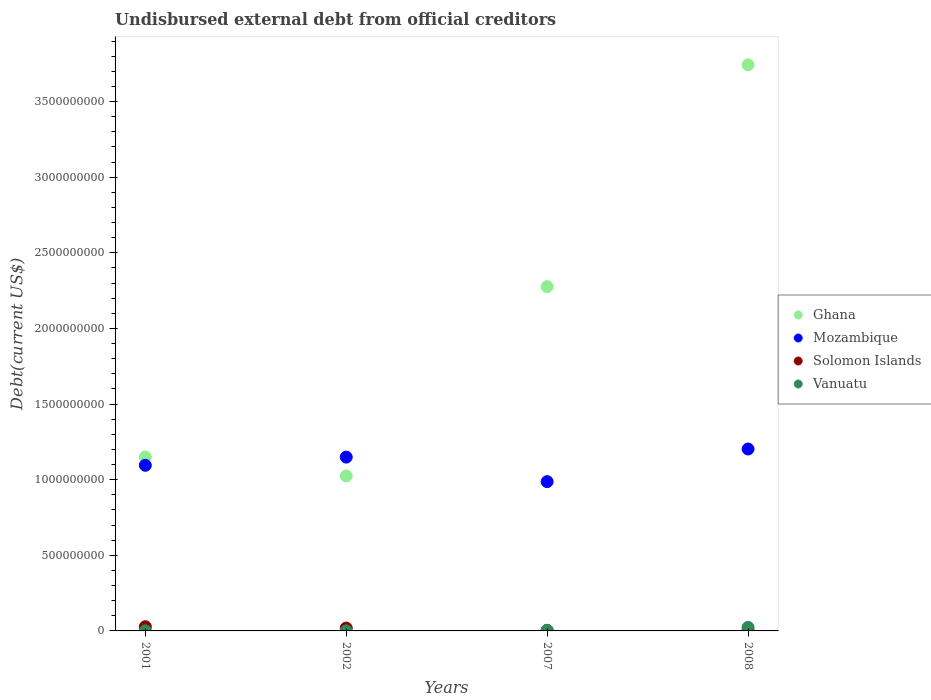How many different coloured dotlines are there?
Provide a short and direct response. 4. Is the number of dotlines equal to the number of legend labels?
Your answer should be very brief. Yes. What is the total debt in Solomon Islands in 2001?
Your response must be concise. 2.78e+07. Across all years, what is the maximum total debt in Mozambique?
Keep it short and to the point. 1.20e+09. Across all years, what is the minimum total debt in Mozambique?
Your response must be concise. 9.87e+08. What is the total total debt in Solomon Islands in the graph?
Offer a terse response. 5.38e+07. What is the difference between the total debt in Mozambique in 2001 and that in 2008?
Offer a very short reply. -1.08e+08. What is the difference between the total debt in Ghana in 2001 and the total debt in Vanuatu in 2007?
Offer a terse response. 1.15e+09. What is the average total debt in Mozambique per year?
Offer a terse response. 1.11e+09. In the year 2001, what is the difference between the total debt in Solomon Islands and total debt in Ghana?
Provide a short and direct response. -1.12e+09. In how many years, is the total debt in Mozambique greater than 3400000000 US$?
Your answer should be compact. 0. What is the ratio of the total debt in Ghana in 2007 to that in 2008?
Your answer should be very brief. 0.61. Is the total debt in Solomon Islands in 2001 less than that in 2002?
Your answer should be compact. No. What is the difference between the highest and the second highest total debt in Vanuatu?
Provide a short and direct response. 1.92e+07. What is the difference between the highest and the lowest total debt in Solomon Islands?
Offer a terse response. 2.43e+07. Is the sum of the total debt in Mozambique in 2002 and 2007 greater than the maximum total debt in Ghana across all years?
Make the answer very short. No. Is it the case that in every year, the sum of the total debt in Mozambique and total debt in Solomon Islands  is greater than the total debt in Vanuatu?
Offer a very short reply. Yes. Does the total debt in Solomon Islands monotonically increase over the years?
Offer a very short reply. No. Is the total debt in Mozambique strictly greater than the total debt in Vanuatu over the years?
Your answer should be compact. Yes. Is the total debt in Mozambique strictly less than the total debt in Solomon Islands over the years?
Ensure brevity in your answer.  No. Are the values on the major ticks of Y-axis written in scientific E-notation?
Offer a terse response. No. Does the graph contain grids?
Make the answer very short. No. How are the legend labels stacked?
Your answer should be very brief. Vertical. What is the title of the graph?
Your answer should be very brief. Undisbursed external debt from official creditors. What is the label or title of the X-axis?
Ensure brevity in your answer.  Years. What is the label or title of the Y-axis?
Ensure brevity in your answer.  Debt(current US$). What is the Debt(current US$) in Ghana in 2001?
Provide a short and direct response. 1.15e+09. What is the Debt(current US$) of Mozambique in 2001?
Make the answer very short. 1.09e+09. What is the Debt(current US$) of Solomon Islands in 2001?
Make the answer very short. 2.78e+07. What is the Debt(current US$) in Vanuatu in 2001?
Provide a short and direct response. 5.09e+05. What is the Debt(current US$) in Ghana in 2002?
Your answer should be very brief. 1.02e+09. What is the Debt(current US$) in Mozambique in 2002?
Ensure brevity in your answer.  1.15e+09. What is the Debt(current US$) in Solomon Islands in 2002?
Offer a very short reply. 1.89e+07. What is the Debt(current US$) of Vanuatu in 2002?
Make the answer very short. 1.20e+04. What is the Debt(current US$) of Ghana in 2007?
Your answer should be compact. 2.28e+09. What is the Debt(current US$) of Mozambique in 2007?
Make the answer very short. 9.87e+08. What is the Debt(current US$) in Solomon Islands in 2007?
Keep it short and to the point. 3.60e+06. What is the Debt(current US$) of Vanuatu in 2007?
Make the answer very short. 4.20e+06. What is the Debt(current US$) of Ghana in 2008?
Keep it short and to the point. 3.74e+09. What is the Debt(current US$) of Mozambique in 2008?
Your response must be concise. 1.20e+09. What is the Debt(current US$) in Solomon Islands in 2008?
Provide a short and direct response. 3.46e+06. What is the Debt(current US$) of Vanuatu in 2008?
Offer a terse response. 2.34e+07. Across all years, what is the maximum Debt(current US$) in Ghana?
Make the answer very short. 3.74e+09. Across all years, what is the maximum Debt(current US$) in Mozambique?
Your answer should be very brief. 1.20e+09. Across all years, what is the maximum Debt(current US$) of Solomon Islands?
Your response must be concise. 2.78e+07. Across all years, what is the maximum Debt(current US$) in Vanuatu?
Your answer should be very brief. 2.34e+07. Across all years, what is the minimum Debt(current US$) of Ghana?
Provide a short and direct response. 1.02e+09. Across all years, what is the minimum Debt(current US$) in Mozambique?
Your answer should be compact. 9.87e+08. Across all years, what is the minimum Debt(current US$) in Solomon Islands?
Give a very brief answer. 3.46e+06. Across all years, what is the minimum Debt(current US$) of Vanuatu?
Make the answer very short. 1.20e+04. What is the total Debt(current US$) of Ghana in the graph?
Your answer should be very brief. 8.19e+09. What is the total Debt(current US$) in Mozambique in the graph?
Keep it short and to the point. 4.43e+09. What is the total Debt(current US$) in Solomon Islands in the graph?
Provide a succinct answer. 5.38e+07. What is the total Debt(current US$) of Vanuatu in the graph?
Provide a succinct answer. 2.82e+07. What is the difference between the Debt(current US$) of Ghana in 2001 and that in 2002?
Ensure brevity in your answer.  1.25e+08. What is the difference between the Debt(current US$) of Mozambique in 2001 and that in 2002?
Provide a succinct answer. -5.41e+07. What is the difference between the Debt(current US$) in Solomon Islands in 2001 and that in 2002?
Your answer should be very brief. 8.89e+06. What is the difference between the Debt(current US$) in Vanuatu in 2001 and that in 2002?
Make the answer very short. 4.97e+05. What is the difference between the Debt(current US$) in Ghana in 2001 and that in 2007?
Your answer should be compact. -1.13e+09. What is the difference between the Debt(current US$) of Mozambique in 2001 and that in 2007?
Your response must be concise. 1.08e+08. What is the difference between the Debt(current US$) of Solomon Islands in 2001 and that in 2007?
Your answer should be very brief. 2.42e+07. What is the difference between the Debt(current US$) in Vanuatu in 2001 and that in 2007?
Keep it short and to the point. -3.69e+06. What is the difference between the Debt(current US$) in Ghana in 2001 and that in 2008?
Provide a succinct answer. -2.59e+09. What is the difference between the Debt(current US$) of Mozambique in 2001 and that in 2008?
Your answer should be compact. -1.08e+08. What is the difference between the Debt(current US$) in Solomon Islands in 2001 and that in 2008?
Make the answer very short. 2.43e+07. What is the difference between the Debt(current US$) in Vanuatu in 2001 and that in 2008?
Ensure brevity in your answer.  -2.29e+07. What is the difference between the Debt(current US$) in Ghana in 2002 and that in 2007?
Offer a very short reply. -1.25e+09. What is the difference between the Debt(current US$) in Mozambique in 2002 and that in 2007?
Offer a terse response. 1.62e+08. What is the difference between the Debt(current US$) in Solomon Islands in 2002 and that in 2007?
Offer a terse response. 1.53e+07. What is the difference between the Debt(current US$) in Vanuatu in 2002 and that in 2007?
Offer a very short reply. -4.19e+06. What is the difference between the Debt(current US$) in Ghana in 2002 and that in 2008?
Your answer should be very brief. -2.72e+09. What is the difference between the Debt(current US$) in Mozambique in 2002 and that in 2008?
Your answer should be very brief. -5.36e+07. What is the difference between the Debt(current US$) of Solomon Islands in 2002 and that in 2008?
Your answer should be very brief. 1.54e+07. What is the difference between the Debt(current US$) of Vanuatu in 2002 and that in 2008?
Provide a short and direct response. -2.34e+07. What is the difference between the Debt(current US$) of Ghana in 2007 and that in 2008?
Provide a succinct answer. -1.47e+09. What is the difference between the Debt(current US$) of Mozambique in 2007 and that in 2008?
Offer a very short reply. -2.16e+08. What is the difference between the Debt(current US$) in Solomon Islands in 2007 and that in 2008?
Make the answer very short. 1.39e+05. What is the difference between the Debt(current US$) of Vanuatu in 2007 and that in 2008?
Make the answer very short. -1.92e+07. What is the difference between the Debt(current US$) of Ghana in 2001 and the Debt(current US$) of Mozambique in 2002?
Provide a succinct answer. 6.77e+05. What is the difference between the Debt(current US$) in Ghana in 2001 and the Debt(current US$) in Solomon Islands in 2002?
Offer a terse response. 1.13e+09. What is the difference between the Debt(current US$) of Ghana in 2001 and the Debt(current US$) of Vanuatu in 2002?
Your answer should be compact. 1.15e+09. What is the difference between the Debt(current US$) in Mozambique in 2001 and the Debt(current US$) in Solomon Islands in 2002?
Keep it short and to the point. 1.08e+09. What is the difference between the Debt(current US$) of Mozambique in 2001 and the Debt(current US$) of Vanuatu in 2002?
Your answer should be very brief. 1.09e+09. What is the difference between the Debt(current US$) of Solomon Islands in 2001 and the Debt(current US$) of Vanuatu in 2002?
Your response must be concise. 2.78e+07. What is the difference between the Debt(current US$) in Ghana in 2001 and the Debt(current US$) in Mozambique in 2007?
Provide a succinct answer. 1.63e+08. What is the difference between the Debt(current US$) of Ghana in 2001 and the Debt(current US$) of Solomon Islands in 2007?
Ensure brevity in your answer.  1.15e+09. What is the difference between the Debt(current US$) in Ghana in 2001 and the Debt(current US$) in Vanuatu in 2007?
Your answer should be very brief. 1.15e+09. What is the difference between the Debt(current US$) in Mozambique in 2001 and the Debt(current US$) in Solomon Islands in 2007?
Ensure brevity in your answer.  1.09e+09. What is the difference between the Debt(current US$) in Mozambique in 2001 and the Debt(current US$) in Vanuatu in 2007?
Give a very brief answer. 1.09e+09. What is the difference between the Debt(current US$) of Solomon Islands in 2001 and the Debt(current US$) of Vanuatu in 2007?
Offer a very short reply. 2.36e+07. What is the difference between the Debt(current US$) in Ghana in 2001 and the Debt(current US$) in Mozambique in 2008?
Provide a short and direct response. -5.29e+07. What is the difference between the Debt(current US$) in Ghana in 2001 and the Debt(current US$) in Solomon Islands in 2008?
Provide a succinct answer. 1.15e+09. What is the difference between the Debt(current US$) in Ghana in 2001 and the Debt(current US$) in Vanuatu in 2008?
Your answer should be very brief. 1.13e+09. What is the difference between the Debt(current US$) in Mozambique in 2001 and the Debt(current US$) in Solomon Islands in 2008?
Provide a short and direct response. 1.09e+09. What is the difference between the Debt(current US$) of Mozambique in 2001 and the Debt(current US$) of Vanuatu in 2008?
Offer a very short reply. 1.07e+09. What is the difference between the Debt(current US$) in Solomon Islands in 2001 and the Debt(current US$) in Vanuatu in 2008?
Offer a very short reply. 4.36e+06. What is the difference between the Debt(current US$) in Ghana in 2002 and the Debt(current US$) in Mozambique in 2007?
Ensure brevity in your answer.  3.77e+07. What is the difference between the Debt(current US$) of Ghana in 2002 and the Debt(current US$) of Solomon Islands in 2007?
Your response must be concise. 1.02e+09. What is the difference between the Debt(current US$) of Ghana in 2002 and the Debt(current US$) of Vanuatu in 2007?
Your answer should be very brief. 1.02e+09. What is the difference between the Debt(current US$) of Mozambique in 2002 and the Debt(current US$) of Solomon Islands in 2007?
Provide a short and direct response. 1.15e+09. What is the difference between the Debt(current US$) of Mozambique in 2002 and the Debt(current US$) of Vanuatu in 2007?
Provide a succinct answer. 1.14e+09. What is the difference between the Debt(current US$) in Solomon Islands in 2002 and the Debt(current US$) in Vanuatu in 2007?
Give a very brief answer. 1.47e+07. What is the difference between the Debt(current US$) in Ghana in 2002 and the Debt(current US$) in Mozambique in 2008?
Your response must be concise. -1.78e+08. What is the difference between the Debt(current US$) in Ghana in 2002 and the Debt(current US$) in Solomon Islands in 2008?
Offer a very short reply. 1.02e+09. What is the difference between the Debt(current US$) in Ghana in 2002 and the Debt(current US$) in Vanuatu in 2008?
Keep it short and to the point. 1.00e+09. What is the difference between the Debt(current US$) in Mozambique in 2002 and the Debt(current US$) in Solomon Islands in 2008?
Offer a terse response. 1.15e+09. What is the difference between the Debt(current US$) of Mozambique in 2002 and the Debt(current US$) of Vanuatu in 2008?
Provide a succinct answer. 1.13e+09. What is the difference between the Debt(current US$) of Solomon Islands in 2002 and the Debt(current US$) of Vanuatu in 2008?
Keep it short and to the point. -4.53e+06. What is the difference between the Debt(current US$) in Ghana in 2007 and the Debt(current US$) in Mozambique in 2008?
Provide a succinct answer. 1.07e+09. What is the difference between the Debt(current US$) in Ghana in 2007 and the Debt(current US$) in Solomon Islands in 2008?
Your answer should be very brief. 2.27e+09. What is the difference between the Debt(current US$) in Ghana in 2007 and the Debt(current US$) in Vanuatu in 2008?
Ensure brevity in your answer.  2.25e+09. What is the difference between the Debt(current US$) in Mozambique in 2007 and the Debt(current US$) in Solomon Islands in 2008?
Your answer should be compact. 9.83e+08. What is the difference between the Debt(current US$) of Mozambique in 2007 and the Debt(current US$) of Vanuatu in 2008?
Offer a terse response. 9.64e+08. What is the difference between the Debt(current US$) of Solomon Islands in 2007 and the Debt(current US$) of Vanuatu in 2008?
Make the answer very short. -1.98e+07. What is the average Debt(current US$) in Ghana per year?
Give a very brief answer. 2.05e+09. What is the average Debt(current US$) in Mozambique per year?
Provide a short and direct response. 1.11e+09. What is the average Debt(current US$) in Solomon Islands per year?
Provide a short and direct response. 1.34e+07. What is the average Debt(current US$) of Vanuatu per year?
Give a very brief answer. 7.04e+06. In the year 2001, what is the difference between the Debt(current US$) in Ghana and Debt(current US$) in Mozambique?
Your response must be concise. 5.48e+07. In the year 2001, what is the difference between the Debt(current US$) of Ghana and Debt(current US$) of Solomon Islands?
Provide a short and direct response. 1.12e+09. In the year 2001, what is the difference between the Debt(current US$) in Ghana and Debt(current US$) in Vanuatu?
Your response must be concise. 1.15e+09. In the year 2001, what is the difference between the Debt(current US$) in Mozambique and Debt(current US$) in Solomon Islands?
Make the answer very short. 1.07e+09. In the year 2001, what is the difference between the Debt(current US$) of Mozambique and Debt(current US$) of Vanuatu?
Your answer should be compact. 1.09e+09. In the year 2001, what is the difference between the Debt(current US$) of Solomon Islands and Debt(current US$) of Vanuatu?
Your answer should be compact. 2.73e+07. In the year 2002, what is the difference between the Debt(current US$) in Ghana and Debt(current US$) in Mozambique?
Make the answer very short. -1.24e+08. In the year 2002, what is the difference between the Debt(current US$) of Ghana and Debt(current US$) of Solomon Islands?
Provide a succinct answer. 1.01e+09. In the year 2002, what is the difference between the Debt(current US$) in Ghana and Debt(current US$) in Vanuatu?
Ensure brevity in your answer.  1.02e+09. In the year 2002, what is the difference between the Debt(current US$) in Mozambique and Debt(current US$) in Solomon Islands?
Keep it short and to the point. 1.13e+09. In the year 2002, what is the difference between the Debt(current US$) in Mozambique and Debt(current US$) in Vanuatu?
Your answer should be very brief. 1.15e+09. In the year 2002, what is the difference between the Debt(current US$) of Solomon Islands and Debt(current US$) of Vanuatu?
Offer a terse response. 1.89e+07. In the year 2007, what is the difference between the Debt(current US$) in Ghana and Debt(current US$) in Mozambique?
Provide a short and direct response. 1.29e+09. In the year 2007, what is the difference between the Debt(current US$) of Ghana and Debt(current US$) of Solomon Islands?
Provide a short and direct response. 2.27e+09. In the year 2007, what is the difference between the Debt(current US$) in Ghana and Debt(current US$) in Vanuatu?
Provide a succinct answer. 2.27e+09. In the year 2007, what is the difference between the Debt(current US$) in Mozambique and Debt(current US$) in Solomon Islands?
Provide a short and direct response. 9.83e+08. In the year 2007, what is the difference between the Debt(current US$) in Mozambique and Debt(current US$) in Vanuatu?
Your answer should be compact. 9.83e+08. In the year 2007, what is the difference between the Debt(current US$) of Solomon Islands and Debt(current US$) of Vanuatu?
Keep it short and to the point. -5.96e+05. In the year 2008, what is the difference between the Debt(current US$) of Ghana and Debt(current US$) of Mozambique?
Provide a short and direct response. 2.54e+09. In the year 2008, what is the difference between the Debt(current US$) in Ghana and Debt(current US$) in Solomon Islands?
Ensure brevity in your answer.  3.74e+09. In the year 2008, what is the difference between the Debt(current US$) in Ghana and Debt(current US$) in Vanuatu?
Offer a terse response. 3.72e+09. In the year 2008, what is the difference between the Debt(current US$) of Mozambique and Debt(current US$) of Solomon Islands?
Offer a very short reply. 1.20e+09. In the year 2008, what is the difference between the Debt(current US$) in Mozambique and Debt(current US$) in Vanuatu?
Ensure brevity in your answer.  1.18e+09. In the year 2008, what is the difference between the Debt(current US$) of Solomon Islands and Debt(current US$) of Vanuatu?
Provide a short and direct response. -2.00e+07. What is the ratio of the Debt(current US$) of Ghana in 2001 to that in 2002?
Make the answer very short. 1.12. What is the ratio of the Debt(current US$) in Mozambique in 2001 to that in 2002?
Keep it short and to the point. 0.95. What is the ratio of the Debt(current US$) in Solomon Islands in 2001 to that in 2002?
Your answer should be compact. 1.47. What is the ratio of the Debt(current US$) of Vanuatu in 2001 to that in 2002?
Ensure brevity in your answer.  42.42. What is the ratio of the Debt(current US$) of Ghana in 2001 to that in 2007?
Offer a terse response. 0.51. What is the ratio of the Debt(current US$) in Mozambique in 2001 to that in 2007?
Ensure brevity in your answer.  1.11. What is the ratio of the Debt(current US$) of Solomon Islands in 2001 to that in 2007?
Ensure brevity in your answer.  7.72. What is the ratio of the Debt(current US$) in Vanuatu in 2001 to that in 2007?
Give a very brief answer. 0.12. What is the ratio of the Debt(current US$) of Ghana in 2001 to that in 2008?
Provide a short and direct response. 0.31. What is the ratio of the Debt(current US$) in Mozambique in 2001 to that in 2008?
Your response must be concise. 0.91. What is the ratio of the Debt(current US$) in Solomon Islands in 2001 to that in 2008?
Offer a very short reply. 8.03. What is the ratio of the Debt(current US$) in Vanuatu in 2001 to that in 2008?
Provide a succinct answer. 0.02. What is the ratio of the Debt(current US$) in Ghana in 2002 to that in 2007?
Your response must be concise. 0.45. What is the ratio of the Debt(current US$) of Mozambique in 2002 to that in 2007?
Ensure brevity in your answer.  1.16. What is the ratio of the Debt(current US$) in Solomon Islands in 2002 to that in 2007?
Provide a succinct answer. 5.25. What is the ratio of the Debt(current US$) in Vanuatu in 2002 to that in 2007?
Give a very brief answer. 0. What is the ratio of the Debt(current US$) of Ghana in 2002 to that in 2008?
Give a very brief answer. 0.27. What is the ratio of the Debt(current US$) of Mozambique in 2002 to that in 2008?
Offer a very short reply. 0.96. What is the ratio of the Debt(current US$) in Solomon Islands in 2002 to that in 2008?
Provide a short and direct response. 5.46. What is the ratio of the Debt(current US$) of Ghana in 2007 to that in 2008?
Offer a terse response. 0.61. What is the ratio of the Debt(current US$) of Mozambique in 2007 to that in 2008?
Make the answer very short. 0.82. What is the ratio of the Debt(current US$) of Solomon Islands in 2007 to that in 2008?
Offer a very short reply. 1.04. What is the ratio of the Debt(current US$) of Vanuatu in 2007 to that in 2008?
Your answer should be very brief. 0.18. What is the difference between the highest and the second highest Debt(current US$) of Ghana?
Offer a very short reply. 1.47e+09. What is the difference between the highest and the second highest Debt(current US$) of Mozambique?
Make the answer very short. 5.36e+07. What is the difference between the highest and the second highest Debt(current US$) of Solomon Islands?
Keep it short and to the point. 8.89e+06. What is the difference between the highest and the second highest Debt(current US$) in Vanuatu?
Offer a terse response. 1.92e+07. What is the difference between the highest and the lowest Debt(current US$) of Ghana?
Provide a succinct answer. 2.72e+09. What is the difference between the highest and the lowest Debt(current US$) of Mozambique?
Provide a succinct answer. 2.16e+08. What is the difference between the highest and the lowest Debt(current US$) of Solomon Islands?
Offer a very short reply. 2.43e+07. What is the difference between the highest and the lowest Debt(current US$) in Vanuatu?
Offer a very short reply. 2.34e+07. 